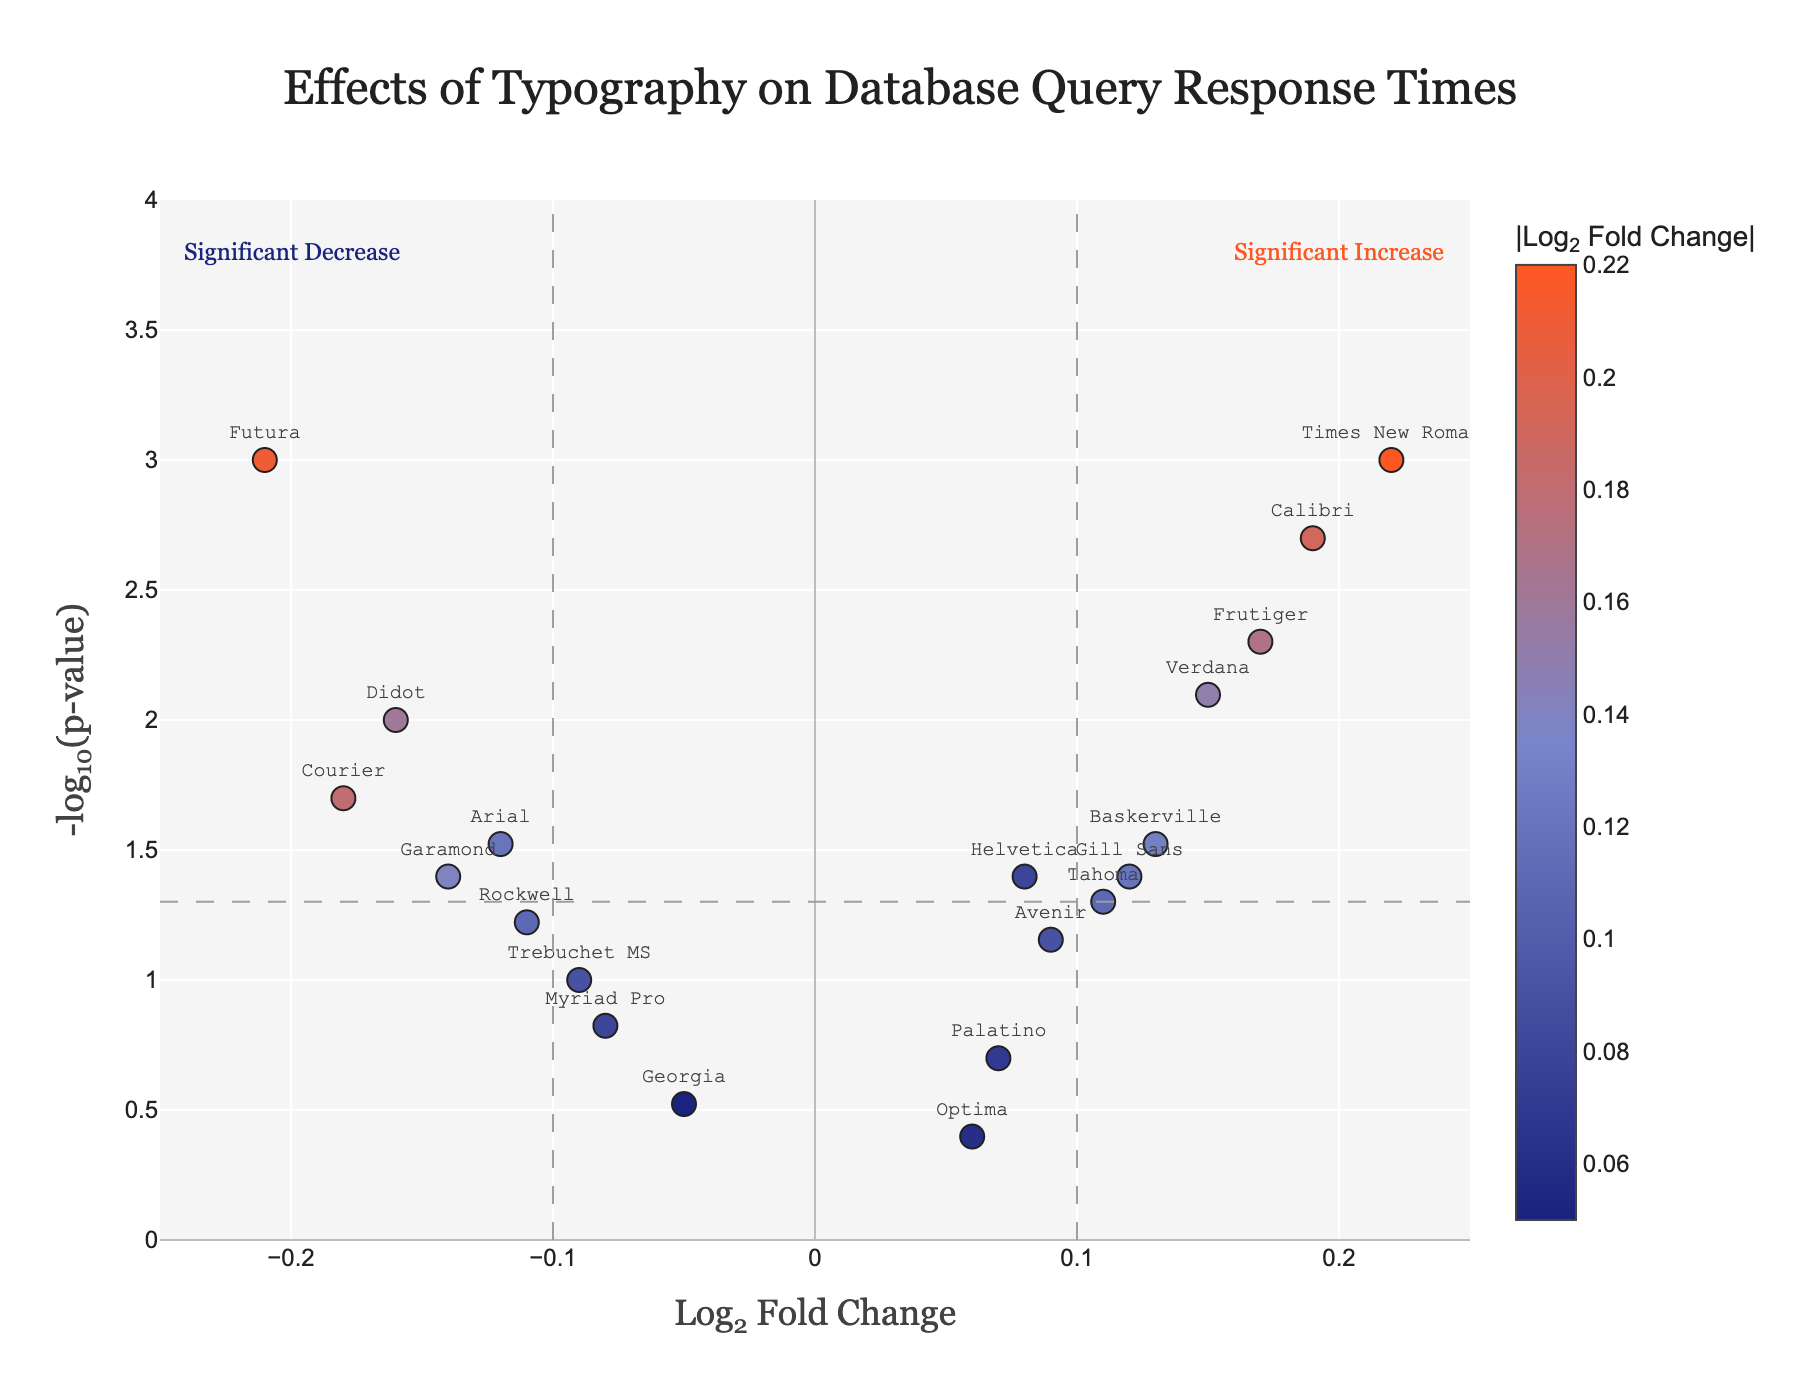How many fonts have a statistically significant Log2 Fold Change? Look for fonts with p-values below 0.05 and count them.
Answer: 11 Which font shows the highest statistically significant increase in performance? Find the font with the highest Log2 Fold Change that also has a p-value below 0.05.
Answer: Times New Roman Which font shows the greatest statistically significant decrease in performance? Find the font with the lowest Log2 Fold Change that also has a p-value below 0.05.
Answer: Futura What is the Log2 Fold Change value for Courier? Identify the data point for Courier and note the Log2 Fold Change value.
Answer: -0.18 How many fonts are not statistically significant? Count the fonts with a p-value greater than 0.05.
Answer: 8 Of the three fonts with the highest Log2 Fold Change values, which are statistically significant? Identify the top three Log2 Fold Change values (Times New Roman, Calibri, Frutiger) and check their p-values.
Answer: All three: Times New Roman, Calibri, Frutiger Which fonts are within one standard deviation of the Log2 Fold Change threshold but not statistically significant? Calculate the standard deviation for the Log2 Fold Change values, then identify fonts within one standard deviation of the 0.1 threshold but with p-values greater than 0.05.
Answer: Tahoma, Trebuchet MS, Avenir, Rockwell, Myriad Pro, Gill Sans How does Arial's performance change relate to the significance threshold? Compare Arial's Log2 Fold Change and p-value to the significance thresholds.
Answer: Arial's Log2 Fold Change is -0.12, which is beyond the threshold in magnitude, and its p-value is significant (0.03) What colors represent the highest and lowest Log2 Fold Change values? The color scale shows colors based on the absolute Log2 Fold Change; check to see which colors are used for the highest positive and negative values.
Answer: Highest: orange-red (#ff5722), Lowest: dark blue (#1a237e) 